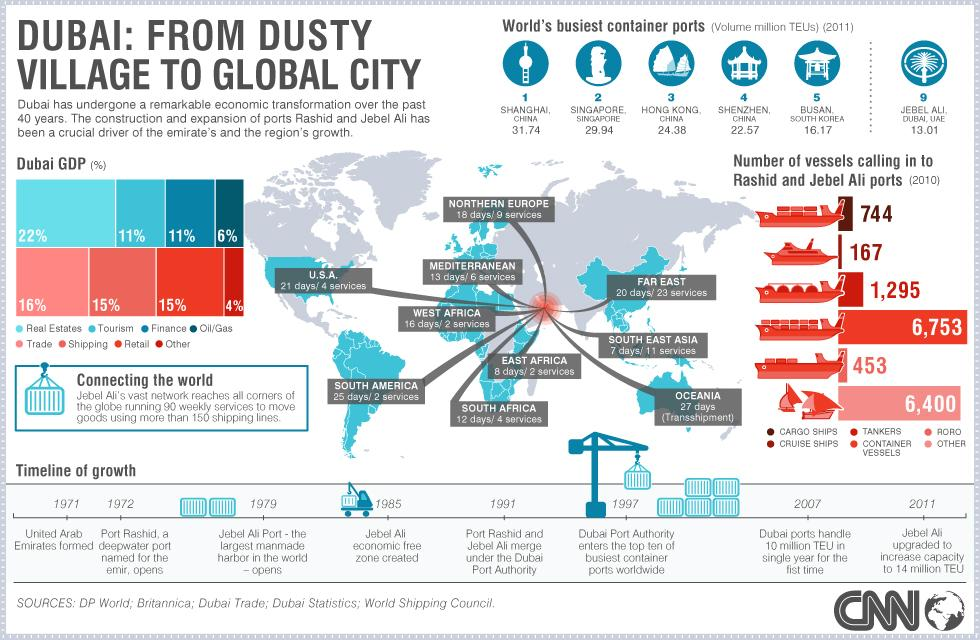Specify some key components in this picture. The contribution of GDP from real estate and shipping is 7% difference. The third lowest number of calls are made to Dubai ports by cargo ships. Dubai's second highest contributor to its Gross Domestic Product (GDP) is trade. The total number of RoRo and container vessels that call into the ports of Dubai is 1,748. Jebel Ali port connects to 10 regions. 